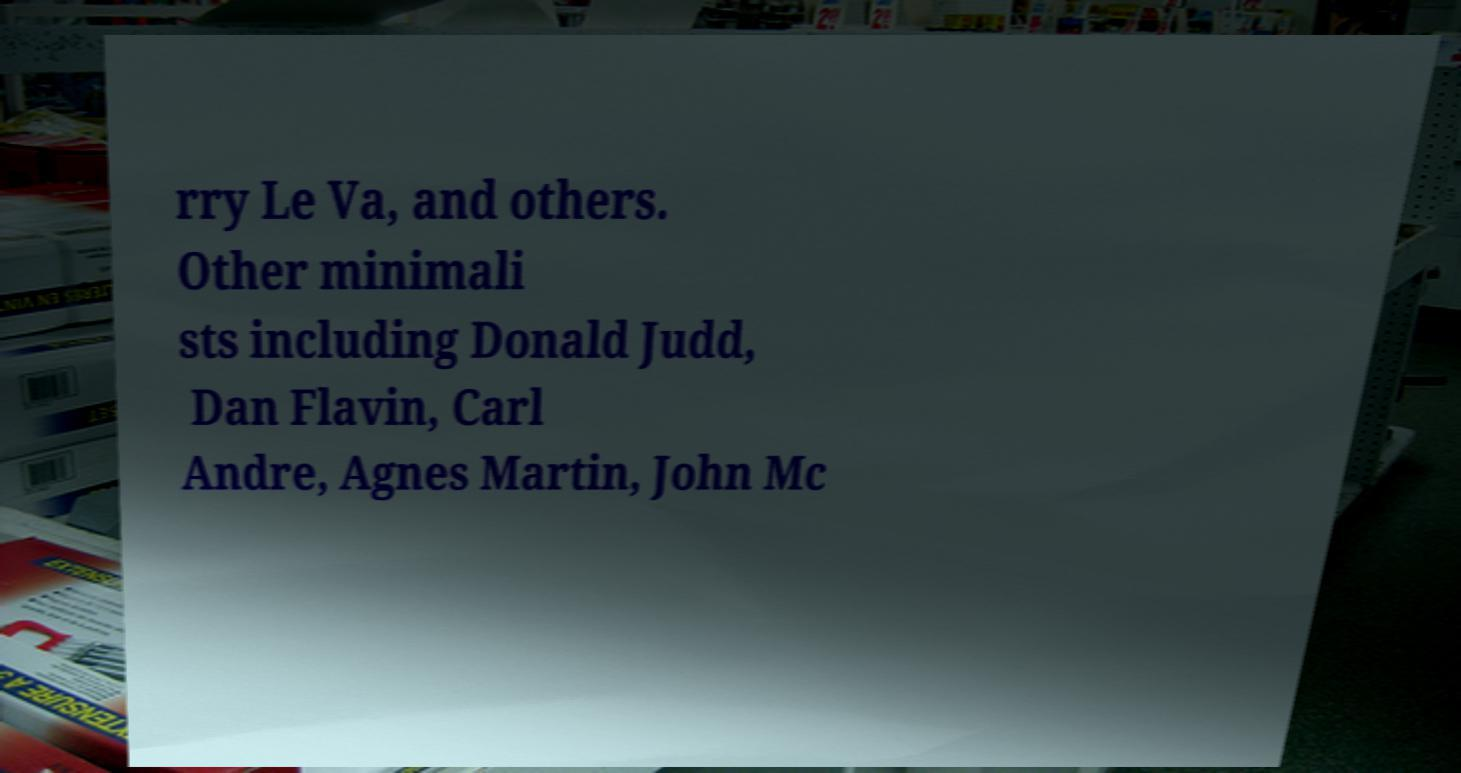Please identify and transcribe the text found in this image. rry Le Va, and others. Other minimali sts including Donald Judd, Dan Flavin, Carl Andre, Agnes Martin, John Mc 